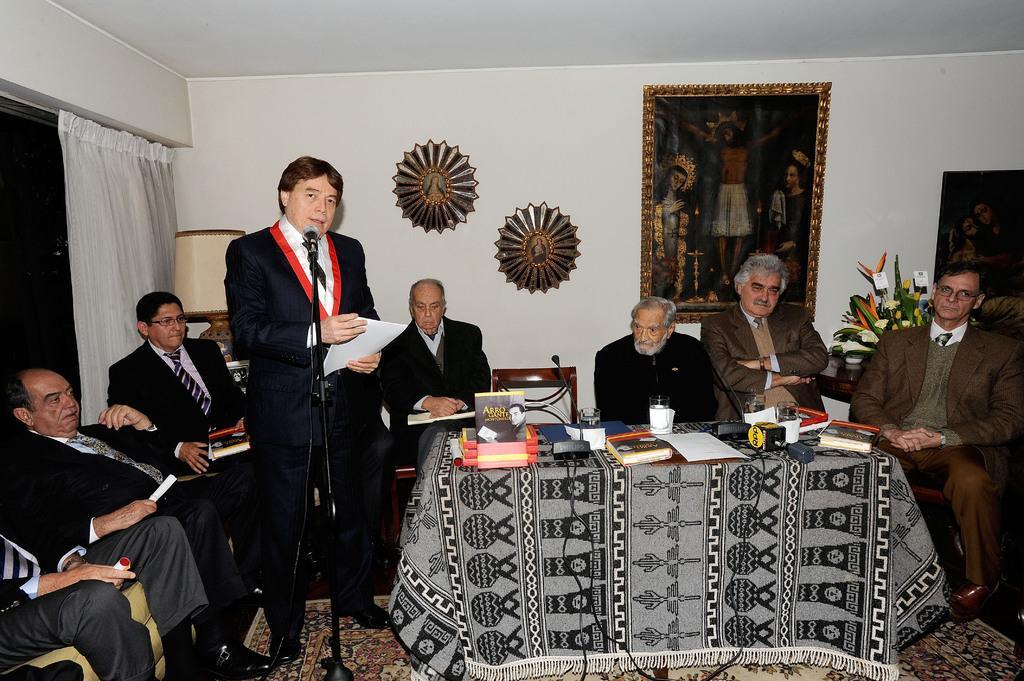Please provide a concise description of this image. In this image I can see number of people where everyone are sitting on chairs. Here I can see a m an is standing in front of a mic. On this table I can see few stuffs. 